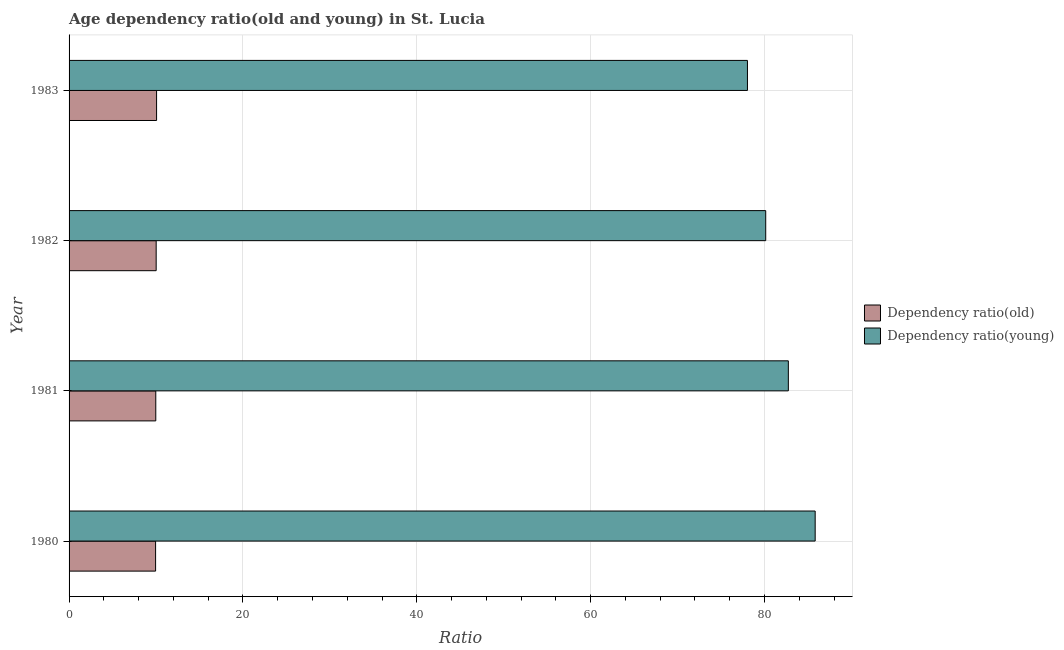How many groups of bars are there?
Provide a succinct answer. 4. Are the number of bars per tick equal to the number of legend labels?
Provide a short and direct response. Yes. How many bars are there on the 1st tick from the top?
Ensure brevity in your answer.  2. What is the label of the 3rd group of bars from the top?
Make the answer very short. 1981. In how many cases, is the number of bars for a given year not equal to the number of legend labels?
Ensure brevity in your answer.  0. What is the age dependency ratio(old) in 1983?
Ensure brevity in your answer.  10.07. Across all years, what is the maximum age dependency ratio(young)?
Your answer should be very brief. 85.83. Across all years, what is the minimum age dependency ratio(old)?
Offer a terse response. 9.95. In which year was the age dependency ratio(old) maximum?
Give a very brief answer. 1983. What is the total age dependency ratio(old) in the graph?
Offer a very short reply. 40.01. What is the difference between the age dependency ratio(young) in 1982 and that in 1983?
Offer a very short reply. 2.1. What is the difference between the age dependency ratio(young) in 1980 and the age dependency ratio(old) in 1982?
Your answer should be compact. 75.81. What is the average age dependency ratio(young) per year?
Offer a terse response. 81.69. In the year 1982, what is the difference between the age dependency ratio(young) and age dependency ratio(old)?
Make the answer very short. 70.12. What is the ratio of the age dependency ratio(young) in 1980 to that in 1981?
Your response must be concise. 1.04. Is the difference between the age dependency ratio(old) in 1980 and 1982 greater than the difference between the age dependency ratio(young) in 1980 and 1982?
Make the answer very short. No. What is the difference between the highest and the second highest age dependency ratio(young)?
Provide a succinct answer. 3.09. What is the difference between the highest and the lowest age dependency ratio(old)?
Keep it short and to the point. 0.11. Is the sum of the age dependency ratio(old) in 1981 and 1982 greater than the maximum age dependency ratio(young) across all years?
Your answer should be compact. No. What does the 2nd bar from the top in 1981 represents?
Give a very brief answer. Dependency ratio(old). What does the 1st bar from the bottom in 1982 represents?
Your answer should be compact. Dependency ratio(old). What is the difference between two consecutive major ticks on the X-axis?
Your answer should be very brief. 20. Does the graph contain any zero values?
Your answer should be very brief. No. Where does the legend appear in the graph?
Offer a very short reply. Center right. How many legend labels are there?
Give a very brief answer. 2. What is the title of the graph?
Your answer should be compact. Age dependency ratio(old and young) in St. Lucia. Does "Lower secondary education" appear as one of the legend labels in the graph?
Provide a succinct answer. No. What is the label or title of the X-axis?
Provide a short and direct response. Ratio. What is the Ratio of Dependency ratio(old) in 1980?
Offer a terse response. 9.95. What is the Ratio of Dependency ratio(young) in 1980?
Your answer should be very brief. 85.83. What is the Ratio of Dependency ratio(old) in 1981?
Your answer should be very brief. 9.97. What is the Ratio in Dependency ratio(young) in 1981?
Your response must be concise. 82.74. What is the Ratio of Dependency ratio(old) in 1982?
Provide a short and direct response. 10.02. What is the Ratio in Dependency ratio(young) in 1982?
Give a very brief answer. 80.14. What is the Ratio in Dependency ratio(old) in 1983?
Your answer should be very brief. 10.07. What is the Ratio of Dependency ratio(young) in 1983?
Keep it short and to the point. 78.04. Across all years, what is the maximum Ratio in Dependency ratio(old)?
Give a very brief answer. 10.07. Across all years, what is the maximum Ratio in Dependency ratio(young)?
Make the answer very short. 85.83. Across all years, what is the minimum Ratio in Dependency ratio(old)?
Your answer should be compact. 9.95. Across all years, what is the minimum Ratio in Dependency ratio(young)?
Provide a succinct answer. 78.04. What is the total Ratio in Dependency ratio(old) in the graph?
Offer a very short reply. 40.01. What is the total Ratio in Dependency ratio(young) in the graph?
Offer a terse response. 326.74. What is the difference between the Ratio of Dependency ratio(old) in 1980 and that in 1981?
Your answer should be very brief. -0.02. What is the difference between the Ratio in Dependency ratio(young) in 1980 and that in 1981?
Make the answer very short. 3.09. What is the difference between the Ratio of Dependency ratio(old) in 1980 and that in 1982?
Your answer should be compact. -0.07. What is the difference between the Ratio in Dependency ratio(young) in 1980 and that in 1982?
Keep it short and to the point. 5.69. What is the difference between the Ratio in Dependency ratio(old) in 1980 and that in 1983?
Keep it short and to the point. -0.11. What is the difference between the Ratio in Dependency ratio(young) in 1980 and that in 1983?
Offer a very short reply. 7.79. What is the difference between the Ratio of Dependency ratio(old) in 1981 and that in 1982?
Provide a succinct answer. -0.04. What is the difference between the Ratio in Dependency ratio(young) in 1981 and that in 1982?
Give a very brief answer. 2.6. What is the difference between the Ratio in Dependency ratio(old) in 1981 and that in 1983?
Provide a short and direct response. -0.09. What is the difference between the Ratio of Dependency ratio(young) in 1981 and that in 1983?
Your answer should be compact. 4.7. What is the difference between the Ratio of Dependency ratio(old) in 1982 and that in 1983?
Provide a short and direct response. -0.05. What is the difference between the Ratio of Dependency ratio(young) in 1982 and that in 1983?
Keep it short and to the point. 2.1. What is the difference between the Ratio in Dependency ratio(old) in 1980 and the Ratio in Dependency ratio(young) in 1981?
Your answer should be compact. -72.79. What is the difference between the Ratio of Dependency ratio(old) in 1980 and the Ratio of Dependency ratio(young) in 1982?
Your answer should be compact. -70.18. What is the difference between the Ratio in Dependency ratio(old) in 1980 and the Ratio in Dependency ratio(young) in 1983?
Make the answer very short. -68.08. What is the difference between the Ratio of Dependency ratio(old) in 1981 and the Ratio of Dependency ratio(young) in 1982?
Keep it short and to the point. -70.16. What is the difference between the Ratio in Dependency ratio(old) in 1981 and the Ratio in Dependency ratio(young) in 1983?
Your answer should be compact. -68.06. What is the difference between the Ratio in Dependency ratio(old) in 1982 and the Ratio in Dependency ratio(young) in 1983?
Provide a succinct answer. -68.02. What is the average Ratio in Dependency ratio(old) per year?
Offer a very short reply. 10. What is the average Ratio in Dependency ratio(young) per year?
Offer a very short reply. 81.68. In the year 1980, what is the difference between the Ratio of Dependency ratio(old) and Ratio of Dependency ratio(young)?
Keep it short and to the point. -75.87. In the year 1981, what is the difference between the Ratio of Dependency ratio(old) and Ratio of Dependency ratio(young)?
Give a very brief answer. -72.77. In the year 1982, what is the difference between the Ratio of Dependency ratio(old) and Ratio of Dependency ratio(young)?
Ensure brevity in your answer.  -70.12. In the year 1983, what is the difference between the Ratio in Dependency ratio(old) and Ratio in Dependency ratio(young)?
Your answer should be very brief. -67.97. What is the ratio of the Ratio of Dependency ratio(old) in 1980 to that in 1981?
Your answer should be very brief. 1. What is the ratio of the Ratio of Dependency ratio(young) in 1980 to that in 1981?
Offer a terse response. 1.04. What is the ratio of the Ratio in Dependency ratio(old) in 1980 to that in 1982?
Give a very brief answer. 0.99. What is the ratio of the Ratio in Dependency ratio(young) in 1980 to that in 1982?
Your answer should be very brief. 1.07. What is the ratio of the Ratio of Dependency ratio(young) in 1980 to that in 1983?
Give a very brief answer. 1.1. What is the ratio of the Ratio in Dependency ratio(young) in 1981 to that in 1982?
Make the answer very short. 1.03. What is the ratio of the Ratio of Dependency ratio(young) in 1981 to that in 1983?
Give a very brief answer. 1.06. What is the ratio of the Ratio of Dependency ratio(young) in 1982 to that in 1983?
Your response must be concise. 1.03. What is the difference between the highest and the second highest Ratio in Dependency ratio(old)?
Provide a succinct answer. 0.05. What is the difference between the highest and the second highest Ratio in Dependency ratio(young)?
Your answer should be compact. 3.09. What is the difference between the highest and the lowest Ratio in Dependency ratio(old)?
Ensure brevity in your answer.  0.11. What is the difference between the highest and the lowest Ratio of Dependency ratio(young)?
Provide a succinct answer. 7.79. 